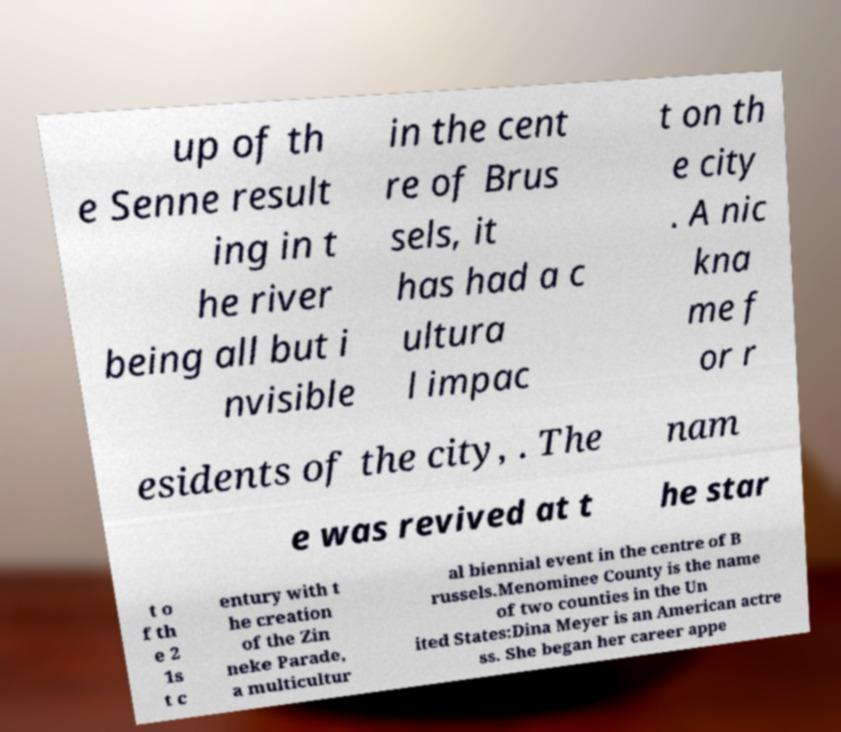Can you accurately transcribe the text from the provided image for me? up of th e Senne result ing in t he river being all but i nvisible in the cent re of Brus sels, it has had a c ultura l impac t on th e city . A nic kna me f or r esidents of the city, . The nam e was revived at t he star t o f th e 2 1s t c entury with t he creation of the Zin neke Parade, a multicultur al biennial event in the centre of B russels.Menominee County is the name of two counties in the Un ited States:Dina Meyer is an American actre ss. She began her career appe 